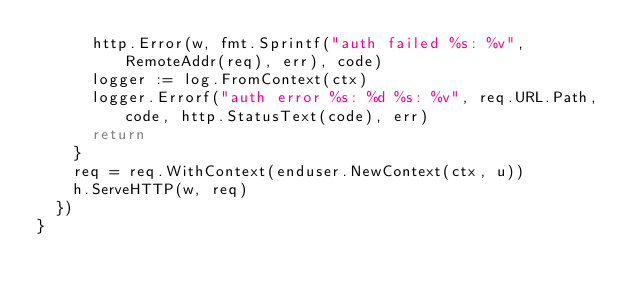<code> <loc_0><loc_0><loc_500><loc_500><_Go_>			http.Error(w, fmt.Sprintf("auth failed %s: %v", RemoteAddr(req), err), code)
			logger := log.FromContext(ctx)
			logger.Errorf("auth error %s: %d %s: %v", req.URL.Path, code, http.StatusText(code), err)
			return
		}
		req = req.WithContext(enduser.NewContext(ctx, u))
		h.ServeHTTP(w, req)
	})
}
</code> 